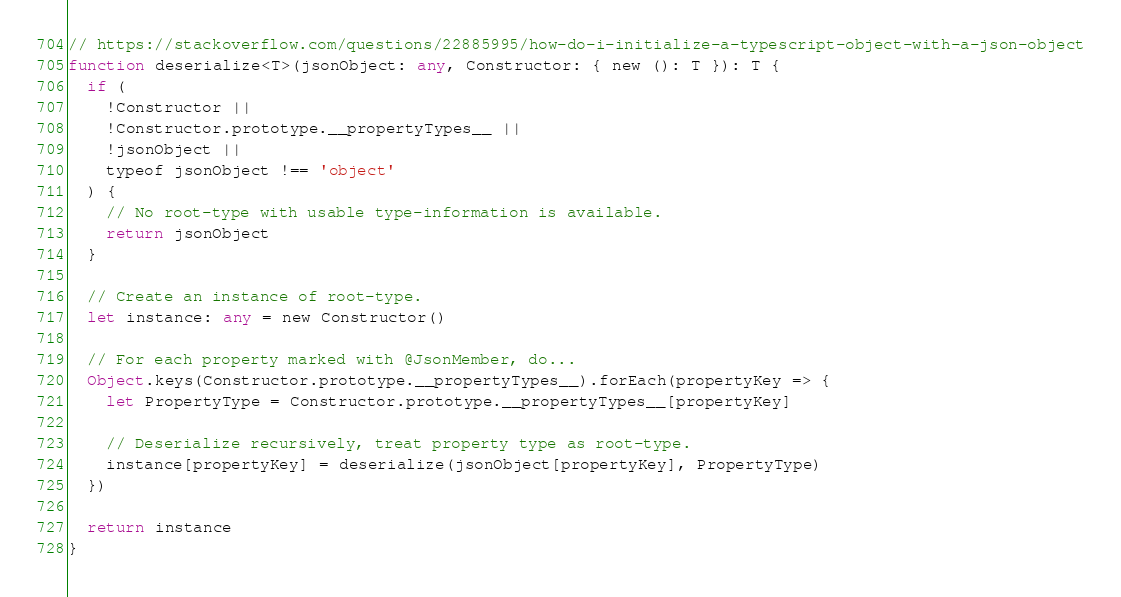Convert code to text. <code><loc_0><loc_0><loc_500><loc_500><_TypeScript_>// https://stackoverflow.com/questions/22885995/how-do-i-initialize-a-typescript-object-with-a-json-object
function deserialize<T>(jsonObject: any, Constructor: { new (): T }): T {
  if (
    !Constructor ||
    !Constructor.prototype.__propertyTypes__ ||
    !jsonObject ||
    typeof jsonObject !== 'object'
  ) {
    // No root-type with usable type-information is available.
    return jsonObject
  }

  // Create an instance of root-type.
  let instance: any = new Constructor()

  // For each property marked with @JsonMember, do...
  Object.keys(Constructor.prototype.__propertyTypes__).forEach(propertyKey => {
    let PropertyType = Constructor.prototype.__propertyTypes__[propertyKey]

    // Deserialize recursively, treat property type as root-type.
    instance[propertyKey] = deserialize(jsonObject[propertyKey], PropertyType)
  })

  return instance
}
</code> 